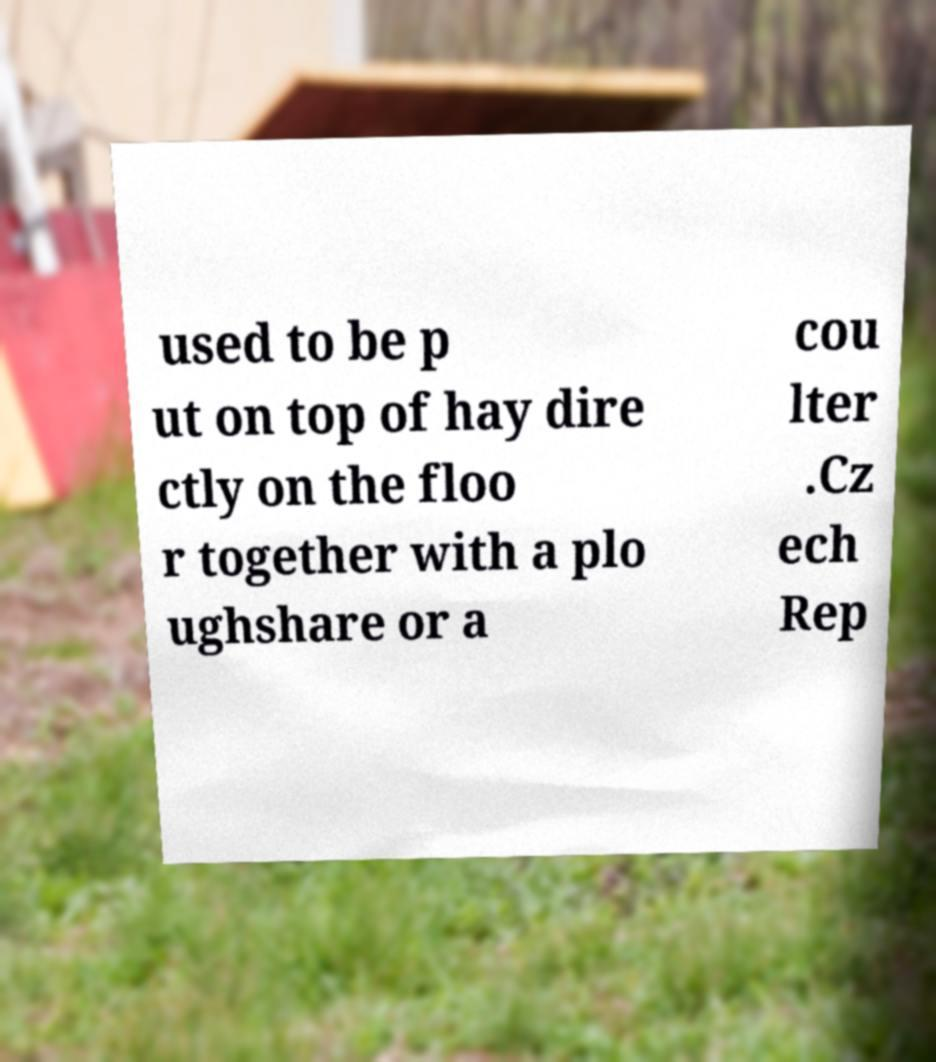For documentation purposes, I need the text within this image transcribed. Could you provide that? used to be p ut on top of hay dire ctly on the floo r together with a plo ughshare or a cou lter .Cz ech Rep 